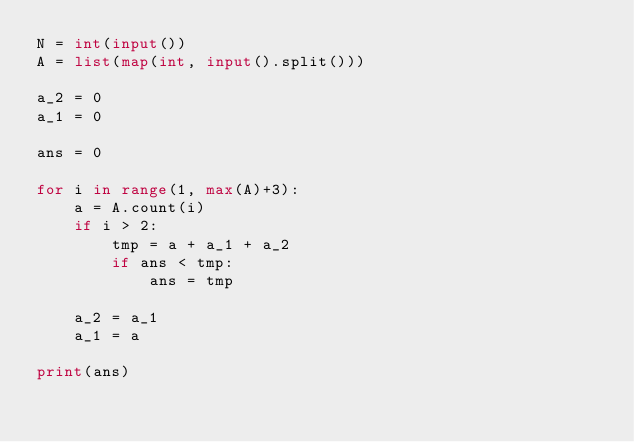Convert code to text. <code><loc_0><loc_0><loc_500><loc_500><_Python_>N = int(input())
A = list(map(int, input().split()))

a_2 = 0
a_1 = 0

ans = 0

for i in range(1, max(A)+3):
    a = A.count(i)
    if i > 2:
        tmp = a + a_1 + a_2
        if ans < tmp:
            ans = tmp
            
    a_2 = a_1
    a_1 = a
            
print(ans)   </code> 